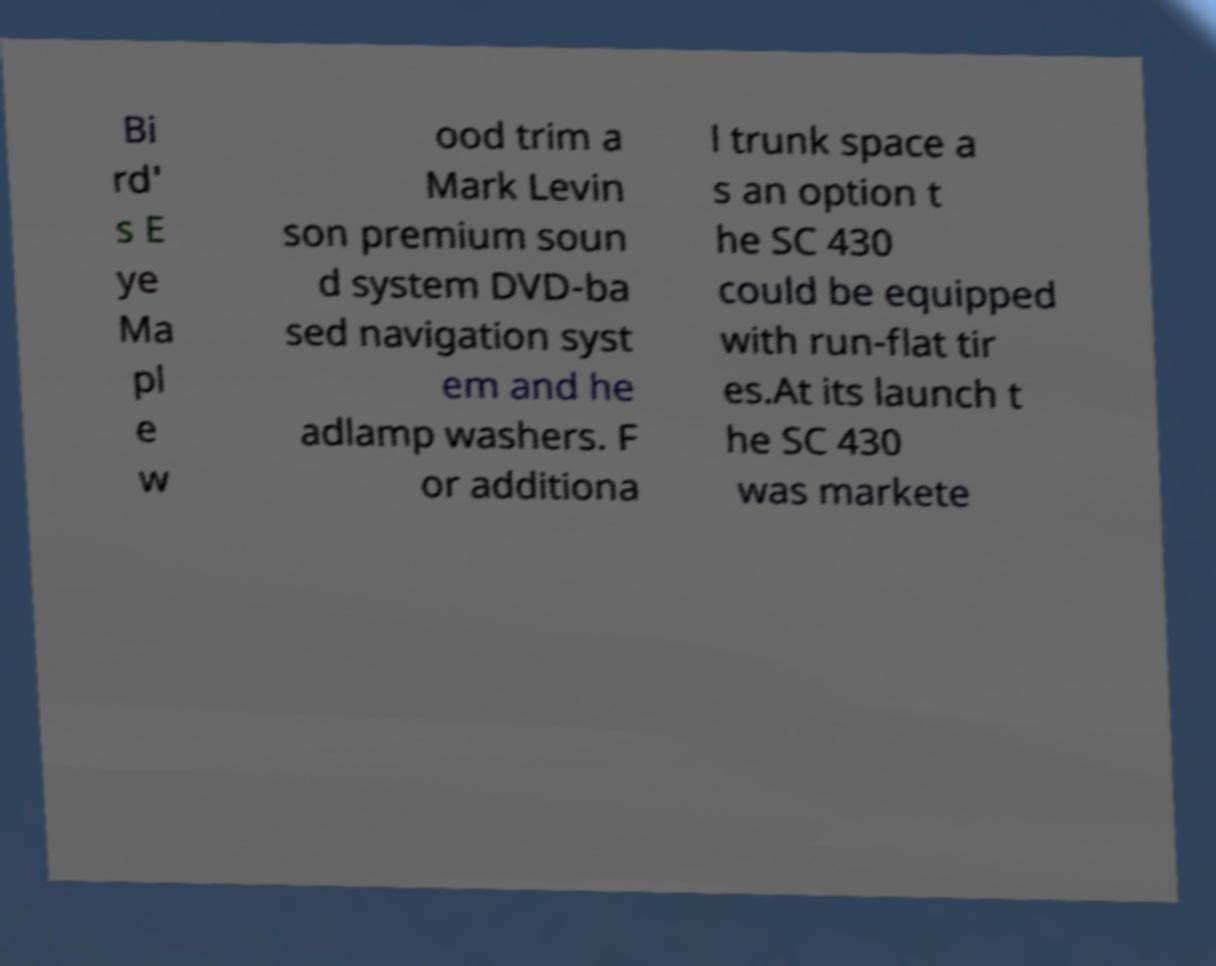Can you read and provide the text displayed in the image?This photo seems to have some interesting text. Can you extract and type it out for me? Bi rd' s E ye Ma pl e w ood trim a Mark Levin son premium soun d system DVD-ba sed navigation syst em and he adlamp washers. F or additiona l trunk space a s an option t he SC 430 could be equipped with run-flat tir es.At its launch t he SC 430 was markete 